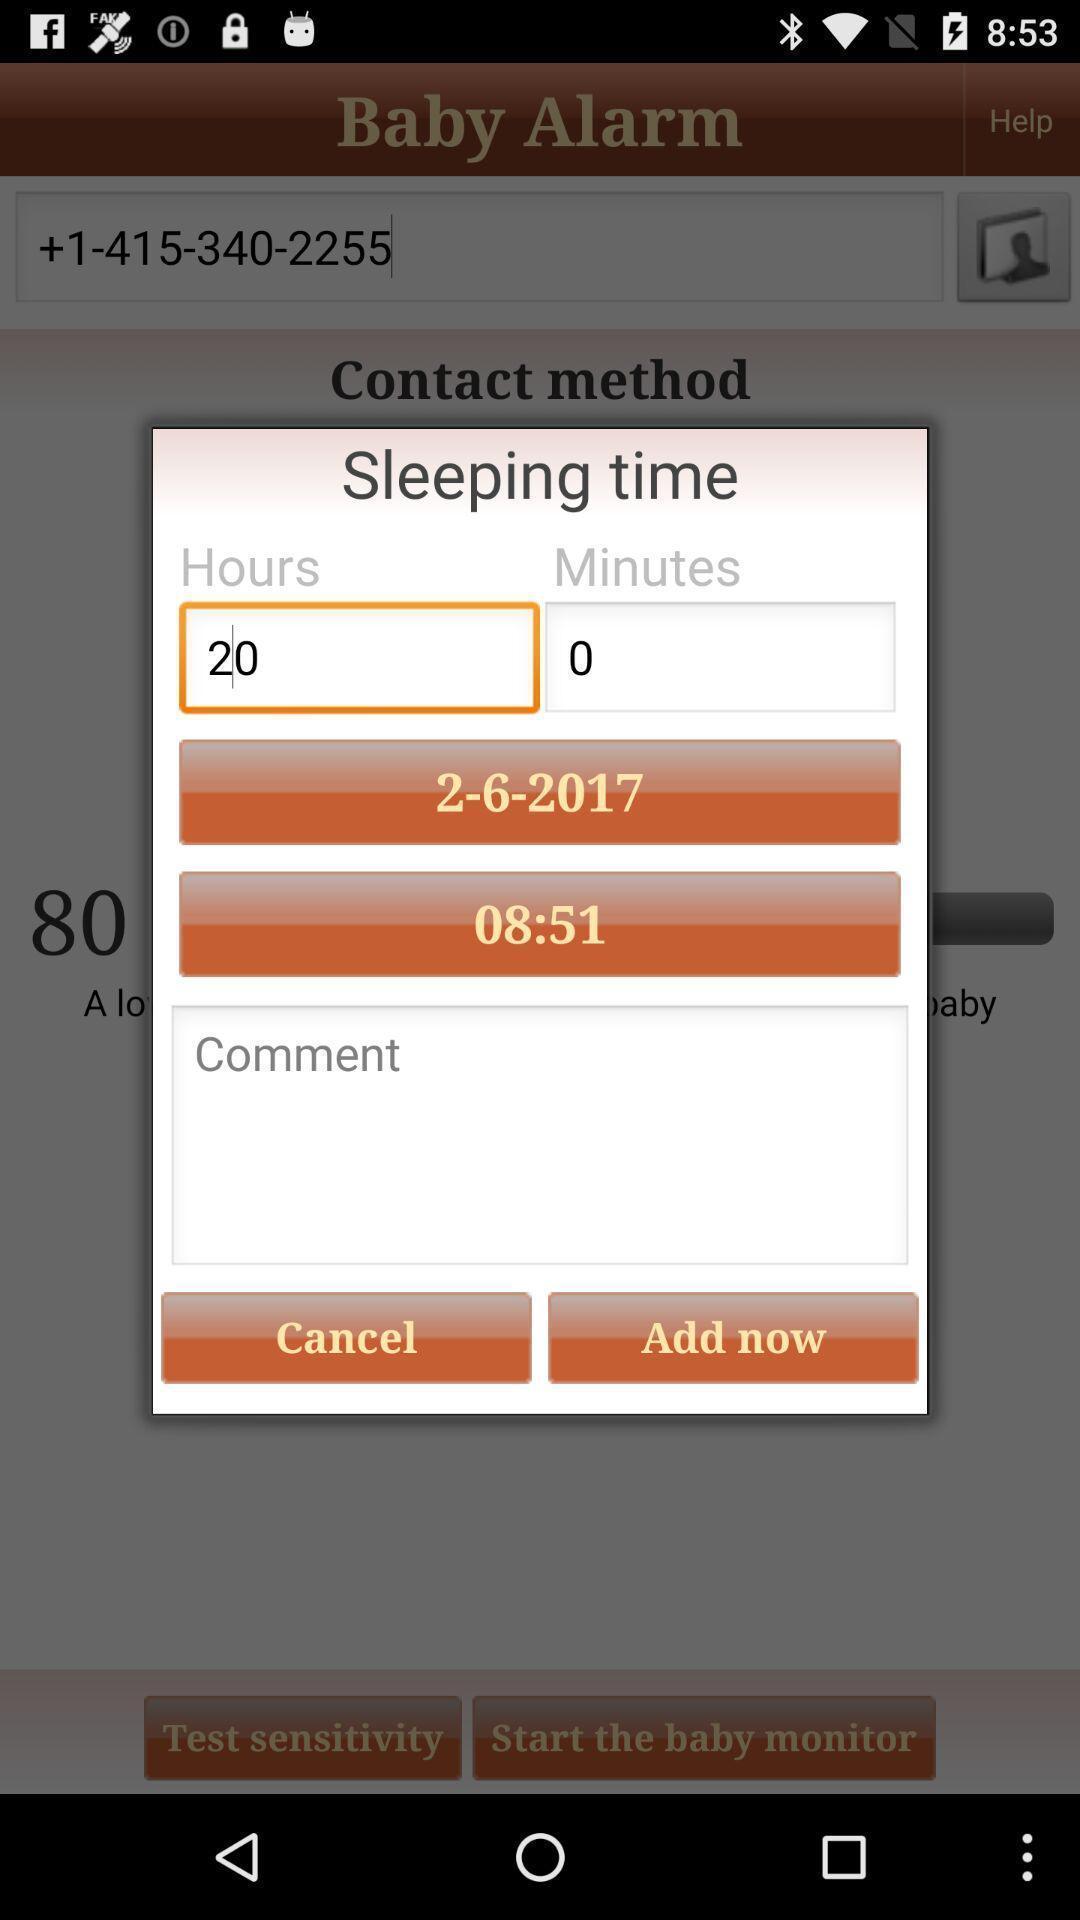Describe the visual elements of this screenshot. Pop-up displaying to set the alarm. 